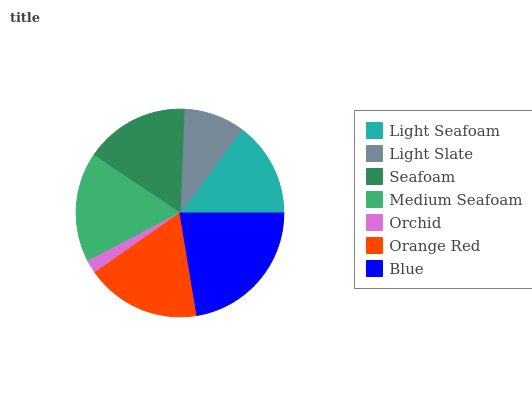Is Orchid the minimum?
Answer yes or no. Yes. Is Blue the maximum?
Answer yes or no. Yes. Is Light Slate the minimum?
Answer yes or no. No. Is Light Slate the maximum?
Answer yes or no. No. Is Light Seafoam greater than Light Slate?
Answer yes or no. Yes. Is Light Slate less than Light Seafoam?
Answer yes or no. Yes. Is Light Slate greater than Light Seafoam?
Answer yes or no. No. Is Light Seafoam less than Light Slate?
Answer yes or no. No. Is Seafoam the high median?
Answer yes or no. Yes. Is Seafoam the low median?
Answer yes or no. Yes. Is Blue the high median?
Answer yes or no. No. Is Light Seafoam the low median?
Answer yes or no. No. 